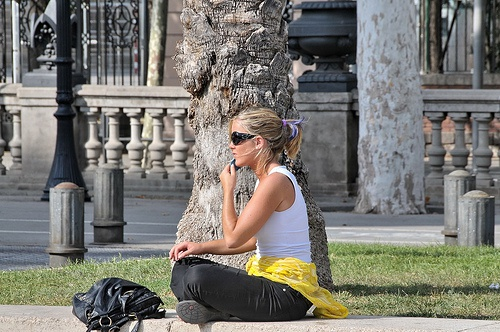Describe the objects in this image and their specific colors. I can see people in black, gray, brown, and tan tones, handbag in black, gray, and darkgray tones, and cell phone in black, navy, blue, and gray tones in this image. 